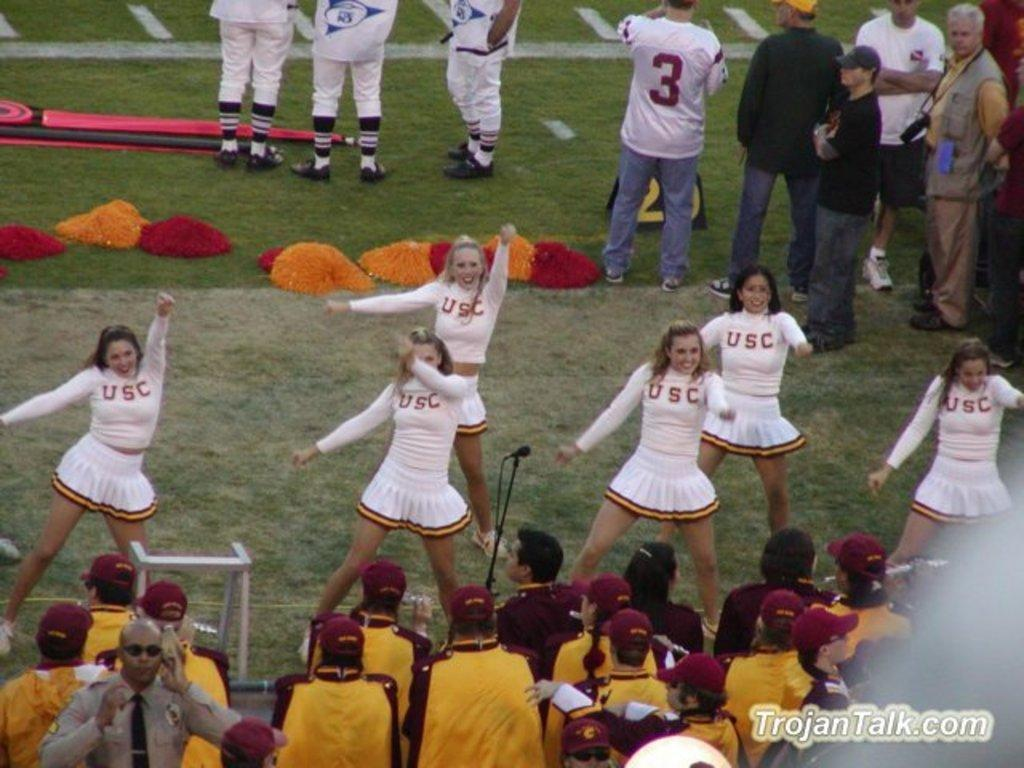<image>
Write a terse but informative summary of the picture. A bunch of U.S.C cheerleaders doing a routine on the field. 